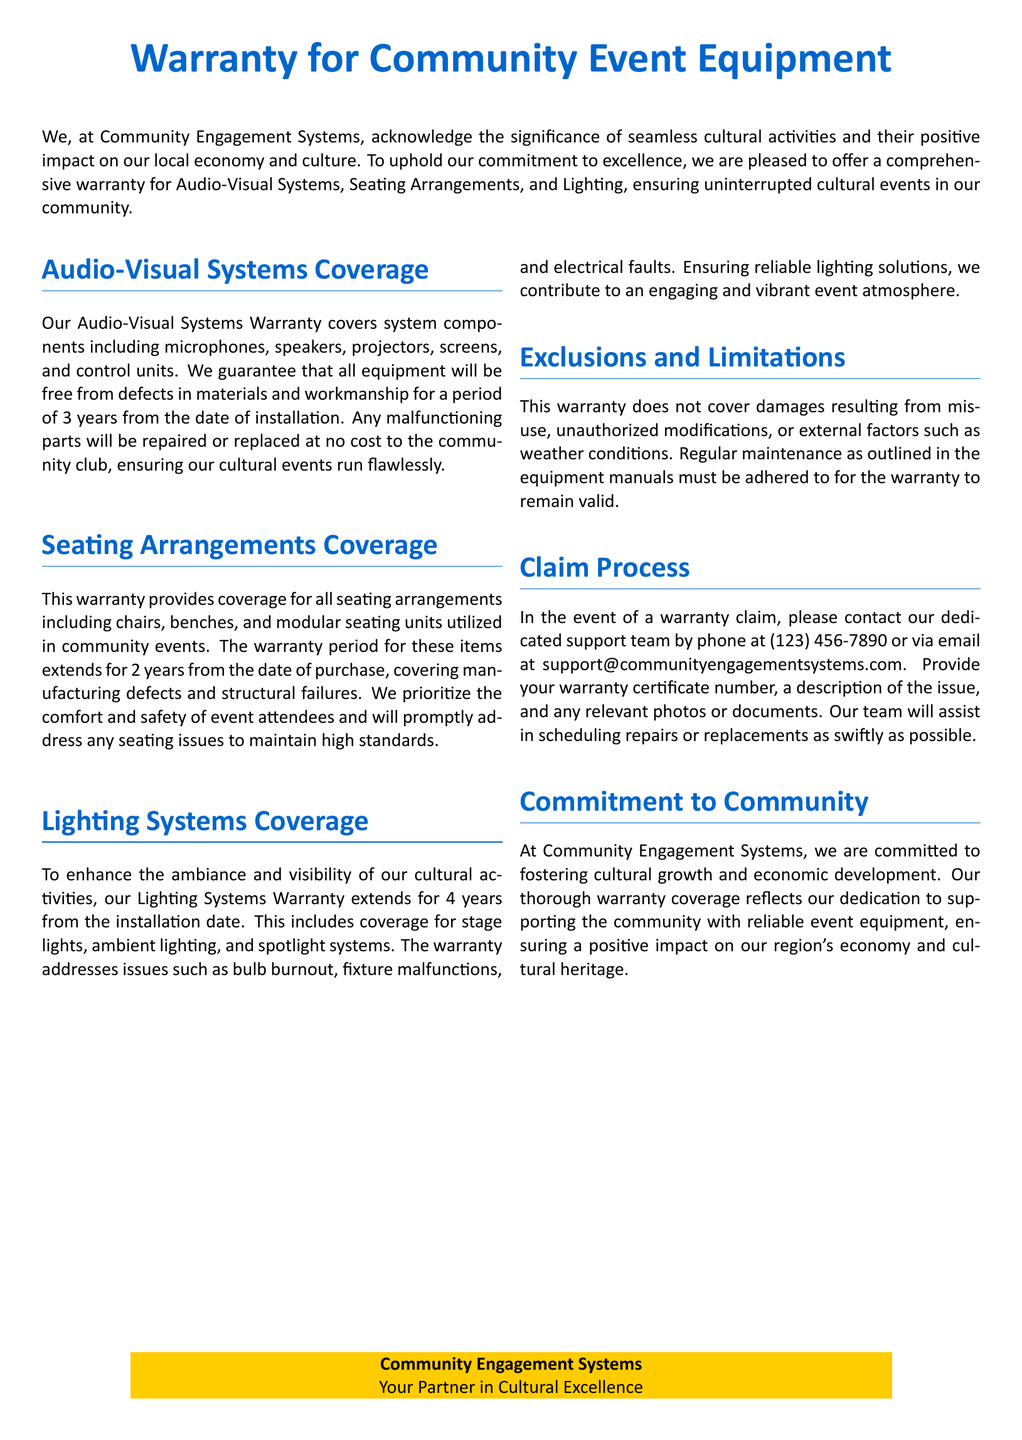What is the warranty period for Audio-Visual Systems? The warranty period for Audio-Visual Systems is 3 years from the date of installation.
Answer: 3 years What items are covered under Seating Arrangements? The items covered under Seating Arrangements include chairs, benches, and modular seating units.
Answer: Chairs, benches, and modular seating units What type of issues does the Lighting Systems Warranty cover? The Lighting Systems Warranty covers issues like bulb burnout, fixture malfunctions, and electrical faults.
Answer: Bulb burnout, fixture malfunctions, and electrical faults What is the duration of the Lighting Systems Warranty? The duration of the Lighting Systems Warranty extends for 4 years from the installation date.
Answer: 4 years How can a warranty claim be initiated? A warranty claim can be initiated by contacting the support team via phone or email and providing specific information like the warranty certificate number and the issue description.
Answer: By contacting support What is excluded from the warranty coverage? Exclusions from the warranty coverage include damages from misuse, unauthorized modifications, or external factors such as weather conditions.
Answer: Misuse and external factors What is the primary focus of the Community Engagement Systems? The primary focus of the Community Engagement Systems is to foster cultural growth and economic development.
Answer: Cultural growth and economic development What is required for the warranty to remain valid? Regular maintenance as outlined in the equipment manuals is required for the warranty to remain valid.
Answer: Regular maintenance What is the color used for section titles in the document? The color used for section titles in the document is a specific RGB color defined as maincolor.
Answer: Maincolor 